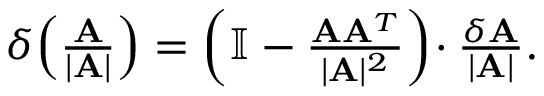<formula> <loc_0><loc_0><loc_500><loc_500>\begin{array} { r } { \delta \, \left ( \frac { A } { | A | } \right ) = \left ( \mathbb { I } - \frac { A A ^ { T } } { | A | ^ { 2 } } \right ) \, \cdot \frac { \delta A } { | A | } . } \end{array}</formula> 